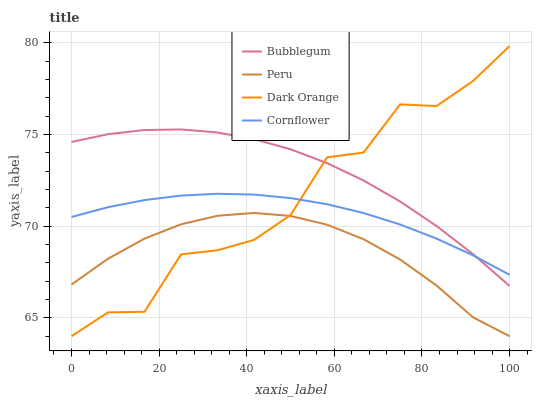Does Peru have the minimum area under the curve?
Answer yes or no. Yes. Does Bubblegum have the maximum area under the curve?
Answer yes or no. Yes. Does Bubblegum have the minimum area under the curve?
Answer yes or no. No. Does Peru have the maximum area under the curve?
Answer yes or no. No. Is Cornflower the smoothest?
Answer yes or no. Yes. Is Dark Orange the roughest?
Answer yes or no. Yes. Is Peru the smoothest?
Answer yes or no. No. Is Peru the roughest?
Answer yes or no. No. Does Bubblegum have the lowest value?
Answer yes or no. No. Does Dark Orange have the highest value?
Answer yes or no. Yes. Does Bubblegum have the highest value?
Answer yes or no. No. Is Peru less than Cornflower?
Answer yes or no. Yes. Is Bubblegum greater than Peru?
Answer yes or no. Yes. Does Dark Orange intersect Cornflower?
Answer yes or no. Yes. Is Dark Orange less than Cornflower?
Answer yes or no. No. Is Dark Orange greater than Cornflower?
Answer yes or no. No. Does Peru intersect Cornflower?
Answer yes or no. No. 